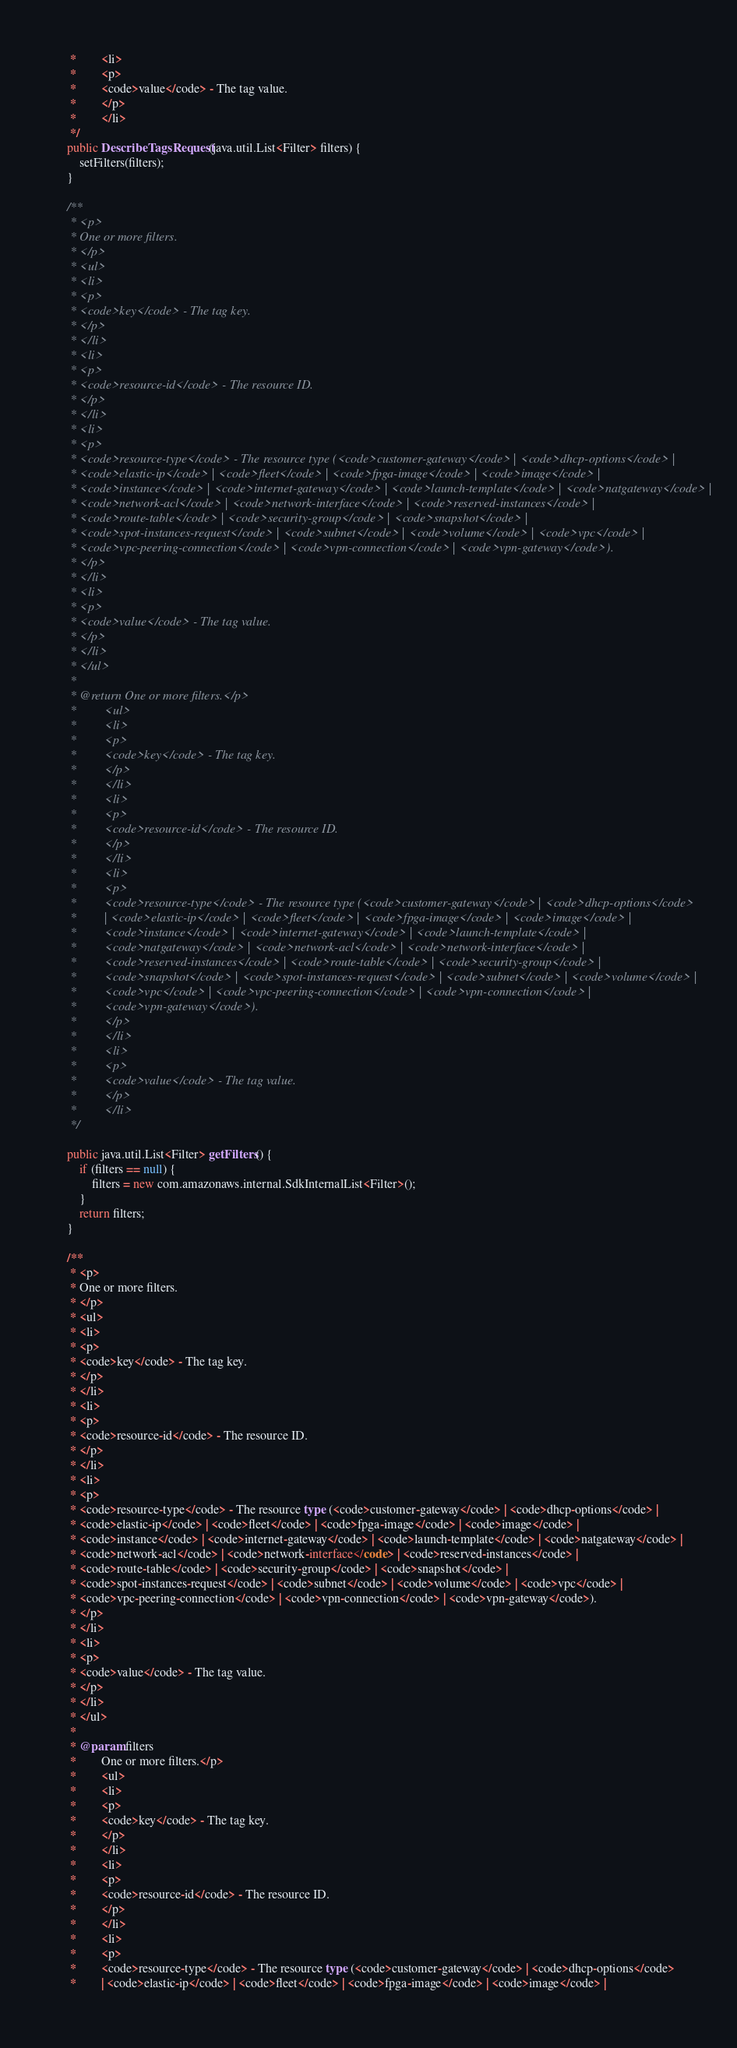Convert code to text. <code><loc_0><loc_0><loc_500><loc_500><_Java_>     *        <li>
     *        <p>
     *        <code>value</code> - The tag value.
     *        </p>
     *        </li>
     */
    public DescribeTagsRequest(java.util.List<Filter> filters) {
        setFilters(filters);
    }

    /**
     * <p>
     * One or more filters.
     * </p>
     * <ul>
     * <li>
     * <p>
     * <code>key</code> - The tag key.
     * </p>
     * </li>
     * <li>
     * <p>
     * <code>resource-id</code> - The resource ID.
     * </p>
     * </li>
     * <li>
     * <p>
     * <code>resource-type</code> - The resource type (<code>customer-gateway</code> | <code>dhcp-options</code> |
     * <code>elastic-ip</code> | <code>fleet</code> | <code>fpga-image</code> | <code>image</code> |
     * <code>instance</code> | <code>internet-gateway</code> | <code>launch-template</code> | <code>natgateway</code> |
     * <code>network-acl</code> | <code>network-interface</code> | <code>reserved-instances</code> |
     * <code>route-table</code> | <code>security-group</code> | <code>snapshot</code> |
     * <code>spot-instances-request</code> | <code>subnet</code> | <code>volume</code> | <code>vpc</code> |
     * <code>vpc-peering-connection</code> | <code>vpn-connection</code> | <code>vpn-gateway</code>).
     * </p>
     * </li>
     * <li>
     * <p>
     * <code>value</code> - The tag value.
     * </p>
     * </li>
     * </ul>
     * 
     * @return One or more filters.</p>
     *         <ul>
     *         <li>
     *         <p>
     *         <code>key</code> - The tag key.
     *         </p>
     *         </li>
     *         <li>
     *         <p>
     *         <code>resource-id</code> - The resource ID.
     *         </p>
     *         </li>
     *         <li>
     *         <p>
     *         <code>resource-type</code> - The resource type (<code>customer-gateway</code> | <code>dhcp-options</code>
     *         | <code>elastic-ip</code> | <code>fleet</code> | <code>fpga-image</code> | <code>image</code> |
     *         <code>instance</code> | <code>internet-gateway</code> | <code>launch-template</code> |
     *         <code>natgateway</code> | <code>network-acl</code> | <code>network-interface</code> |
     *         <code>reserved-instances</code> | <code>route-table</code> | <code>security-group</code> |
     *         <code>snapshot</code> | <code>spot-instances-request</code> | <code>subnet</code> | <code>volume</code> |
     *         <code>vpc</code> | <code>vpc-peering-connection</code> | <code>vpn-connection</code> |
     *         <code>vpn-gateway</code>).
     *         </p>
     *         </li>
     *         <li>
     *         <p>
     *         <code>value</code> - The tag value.
     *         </p>
     *         </li>
     */

    public java.util.List<Filter> getFilters() {
        if (filters == null) {
            filters = new com.amazonaws.internal.SdkInternalList<Filter>();
        }
        return filters;
    }

    /**
     * <p>
     * One or more filters.
     * </p>
     * <ul>
     * <li>
     * <p>
     * <code>key</code> - The tag key.
     * </p>
     * </li>
     * <li>
     * <p>
     * <code>resource-id</code> - The resource ID.
     * </p>
     * </li>
     * <li>
     * <p>
     * <code>resource-type</code> - The resource type (<code>customer-gateway</code> | <code>dhcp-options</code> |
     * <code>elastic-ip</code> | <code>fleet</code> | <code>fpga-image</code> | <code>image</code> |
     * <code>instance</code> | <code>internet-gateway</code> | <code>launch-template</code> | <code>natgateway</code> |
     * <code>network-acl</code> | <code>network-interface</code> | <code>reserved-instances</code> |
     * <code>route-table</code> | <code>security-group</code> | <code>snapshot</code> |
     * <code>spot-instances-request</code> | <code>subnet</code> | <code>volume</code> | <code>vpc</code> |
     * <code>vpc-peering-connection</code> | <code>vpn-connection</code> | <code>vpn-gateway</code>).
     * </p>
     * </li>
     * <li>
     * <p>
     * <code>value</code> - The tag value.
     * </p>
     * </li>
     * </ul>
     * 
     * @param filters
     *        One or more filters.</p>
     *        <ul>
     *        <li>
     *        <p>
     *        <code>key</code> - The tag key.
     *        </p>
     *        </li>
     *        <li>
     *        <p>
     *        <code>resource-id</code> - The resource ID.
     *        </p>
     *        </li>
     *        <li>
     *        <p>
     *        <code>resource-type</code> - The resource type (<code>customer-gateway</code> | <code>dhcp-options</code>
     *        | <code>elastic-ip</code> | <code>fleet</code> | <code>fpga-image</code> | <code>image</code> |</code> 